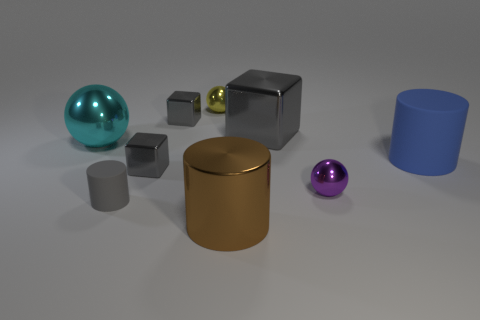Add 1 rubber cylinders. How many objects exist? 10 Subtract all tiny gray blocks. How many blocks are left? 1 Subtract all cubes. How many objects are left? 6 Add 8 large matte cylinders. How many large matte cylinders are left? 9 Add 7 small red rubber blocks. How many small red rubber blocks exist? 7 Subtract all blue cylinders. How many cylinders are left? 2 Subtract 0 brown blocks. How many objects are left? 9 Subtract 3 cylinders. How many cylinders are left? 0 Subtract all yellow cubes. Subtract all gray cylinders. How many cubes are left? 3 Subtract all yellow cubes. How many purple cylinders are left? 0 